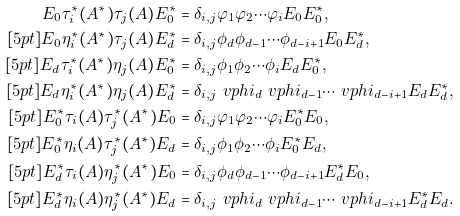Convert formula to latex. <formula><loc_0><loc_0><loc_500><loc_500>E _ { 0 } \tau ^ { * } _ { i } ( A ^ { * } ) \tau _ { j } ( A ) E ^ { * } _ { 0 } & = \delta _ { i , j } \varphi _ { 1 } \varphi _ { 2 } \cdots \varphi _ { i } E _ { 0 } E ^ { * } _ { 0 } , \\ [ 5 p t ] E _ { 0 } \eta ^ { * } _ { i } ( A ^ { * } ) \tau _ { j } ( A ) E ^ { * } _ { d } & = \delta _ { i , j } \phi _ { d } \phi _ { d - 1 } \cdots \phi _ { d - i + 1 } E _ { 0 } E ^ { * } _ { d } , \\ [ 5 p t ] E _ { d } \tau ^ { * } _ { i } ( A ^ { * } ) \eta _ { j } ( A ) E ^ { * } _ { 0 } & = \delta _ { i , j } \phi _ { 1 } \phi _ { 2 } \cdots \phi _ { i } E _ { d } E ^ { * } _ { 0 } , \\ [ 5 p t ] E _ { d } \eta ^ { * } _ { i } ( A ^ { * } ) \eta _ { j } ( A ) E ^ { * } _ { d } & = \delta _ { i , j } \ v p h i _ { d } \ v p h i _ { d - 1 } \cdots \ v p h i _ { d - i + 1 } E _ { d } E ^ { * } _ { d } , \\ [ 5 p t ] E ^ { * } _ { 0 } \tau _ { i } ( A ) \tau ^ { * } _ { j } ( A ^ { * } ) E _ { 0 } & = \delta _ { i , j } \varphi _ { 1 } \varphi _ { 2 } \cdots \varphi _ { i } E ^ { * } _ { 0 } E _ { 0 } , \\ [ 5 p t ] E ^ { * } _ { 0 } \eta _ { i } ( A ) \tau ^ { * } _ { j } ( A ^ { * } ) E _ { d } & = \delta _ { i , j } \phi _ { 1 } \phi _ { 2 } \cdots \phi _ { i } E ^ { * } _ { 0 } E _ { d } , \\ [ 5 p t ] E ^ { * } _ { d } \tau _ { i } ( A ) \eta ^ { * } _ { j } ( A ^ { * } ) E _ { 0 } & = \delta _ { i , j } \phi _ { d } \phi _ { d - 1 } \cdots \phi _ { d - i + 1 } E ^ { * } _ { d } E _ { 0 } , \\ [ 5 p t ] E ^ { * } _ { d } \eta _ { i } ( A ) \eta ^ { * } _ { j } ( A ^ { * } ) E _ { d } & = \delta _ { i , j } \ v p h i _ { d } \ v p h i _ { d - 1 } \cdots \ v p h i _ { d - i + 1 } E ^ { * } _ { d } E _ { d } .</formula> 